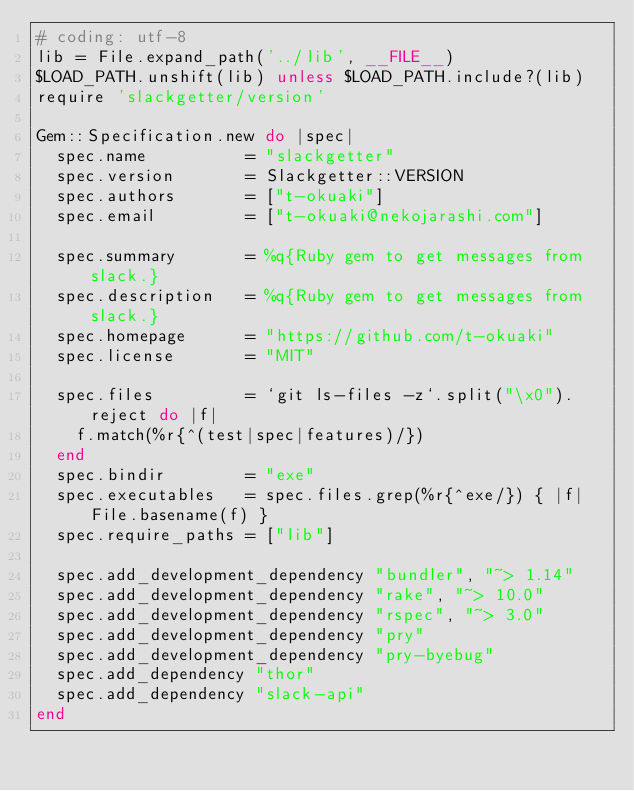<code> <loc_0><loc_0><loc_500><loc_500><_Ruby_># coding: utf-8
lib = File.expand_path('../lib', __FILE__)
$LOAD_PATH.unshift(lib) unless $LOAD_PATH.include?(lib)
require 'slackgetter/version'

Gem::Specification.new do |spec|
  spec.name          = "slackgetter"
  spec.version       = Slackgetter::VERSION
  spec.authors       = ["t-okuaki"]
  spec.email         = ["t-okuaki@nekojarashi.com"]

  spec.summary       = %q{Ruby gem to get messages from slack.}
  spec.description   = %q{Ruby gem to get messages from slack.}
  spec.homepage      = "https://github.com/t-okuaki"
  spec.license       = "MIT"

  spec.files         = `git ls-files -z`.split("\x0").reject do |f|
    f.match(%r{^(test|spec|features)/})
  end
  spec.bindir        = "exe"
  spec.executables   = spec.files.grep(%r{^exe/}) { |f| File.basename(f) }
  spec.require_paths = ["lib"]

  spec.add_development_dependency "bundler", "~> 1.14"
  spec.add_development_dependency "rake", "~> 10.0"
  spec.add_development_dependency "rspec", "~> 3.0"
  spec.add_development_dependency "pry"
  spec.add_development_dependency "pry-byebug"
  spec.add_dependency "thor"
  spec.add_dependency "slack-api"
end
</code> 